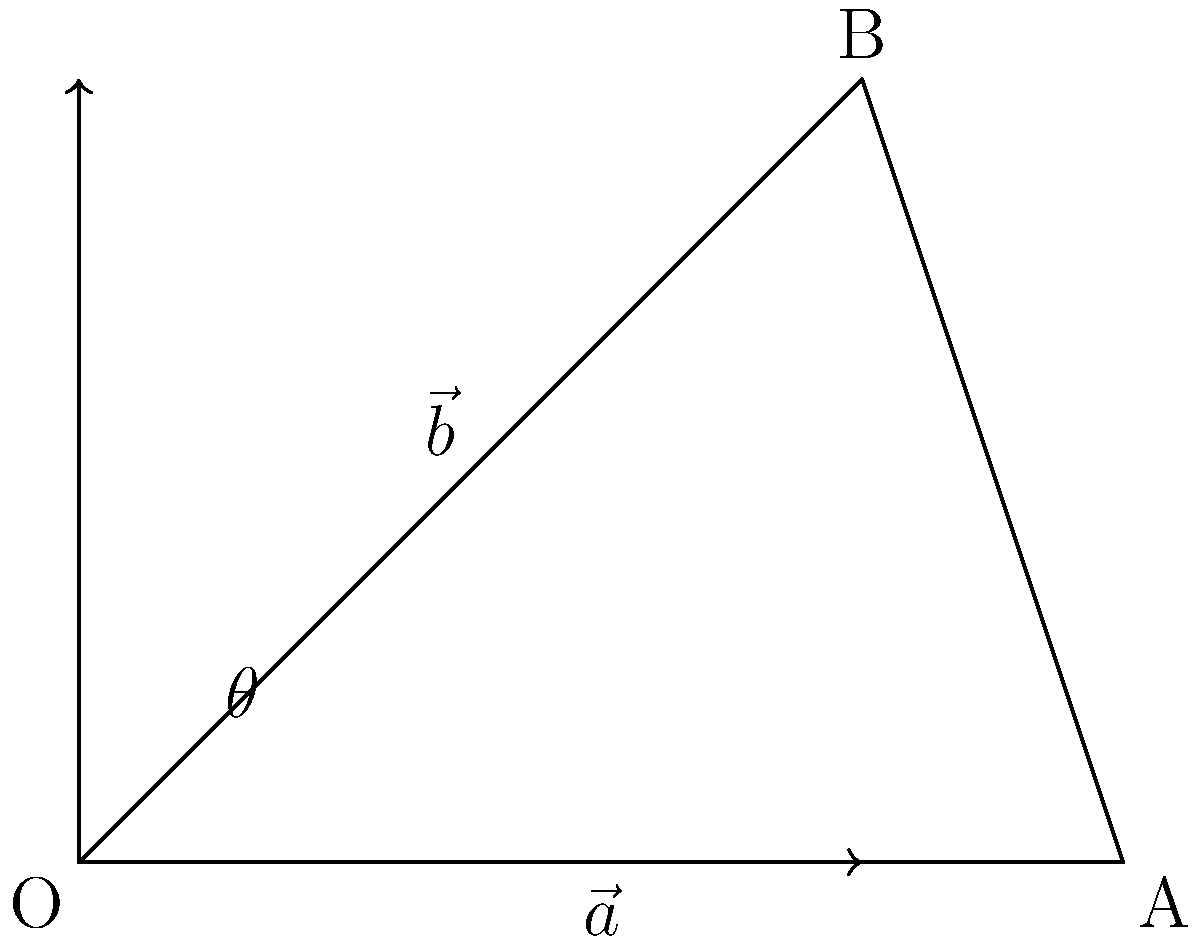As part of planning the optimal location for a new brick-and-mortar store, you need to determine the angle between two streets to maximize store visibility. Given two vectors $\vec{a} = (4,0)$ and $\vec{b} = (3,3)$ representing the directions of the streets, calculate the angle $\theta$ between them using vector operations. To find the angle between two vectors, we can use the dot product formula:

$$\cos \theta = \frac{\vec{a} \cdot \vec{b}}{|\vec{a}||\vec{b}|}$$

Step 1: Calculate the dot product $\vec{a} \cdot \vec{b}$
$\vec{a} \cdot \vec{b} = (4)(3) + (0)(3) = 12$

Step 2: Calculate the magnitudes of $\vec{a}$ and $\vec{b}$
$|\vec{a}| = \sqrt{4^2 + 0^2} = 4$
$|\vec{b}| = \sqrt{3^2 + 3^2} = 3\sqrt{2}$

Step 3: Substitute into the formula
$$\cos \theta = \frac{12}{4(3\sqrt{2})} = \frac{\sqrt{2}}{2}$$

Step 4: Take the inverse cosine (arccos) of both sides
$$\theta = \arccos(\frac{\sqrt{2}}{2})$$

Step 5: Calculate the result (in degrees)
$\theta \approx 45°$

This angle provides the optimal visibility for the store when positioned at the intersection of these two streets.
Answer: $45°$ 